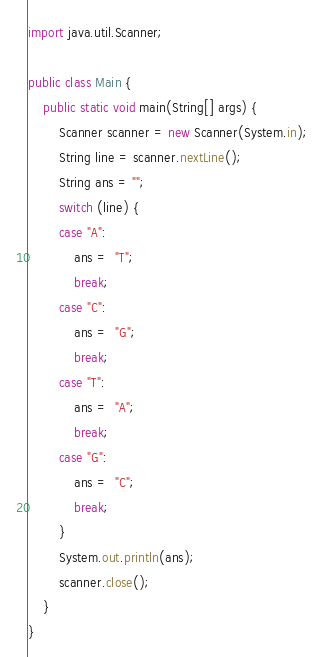<code> <loc_0><loc_0><loc_500><loc_500><_Java_>import java.util.Scanner;

public class Main {
	public static void main(String[] args) {
		Scanner scanner = new Scanner(System.in);
		String line = scanner.nextLine();
		String ans = "";
		switch (line) {
		case "A":
			ans =  "T";
			break;
		case "C":
			ans =  "G";
			break;
		case "T":
			ans =  "A";
			break;
		case "G":
			ans =  "C";
			break;
		}
		System.out.println(ans);
		scanner.close();
	}
}
</code> 